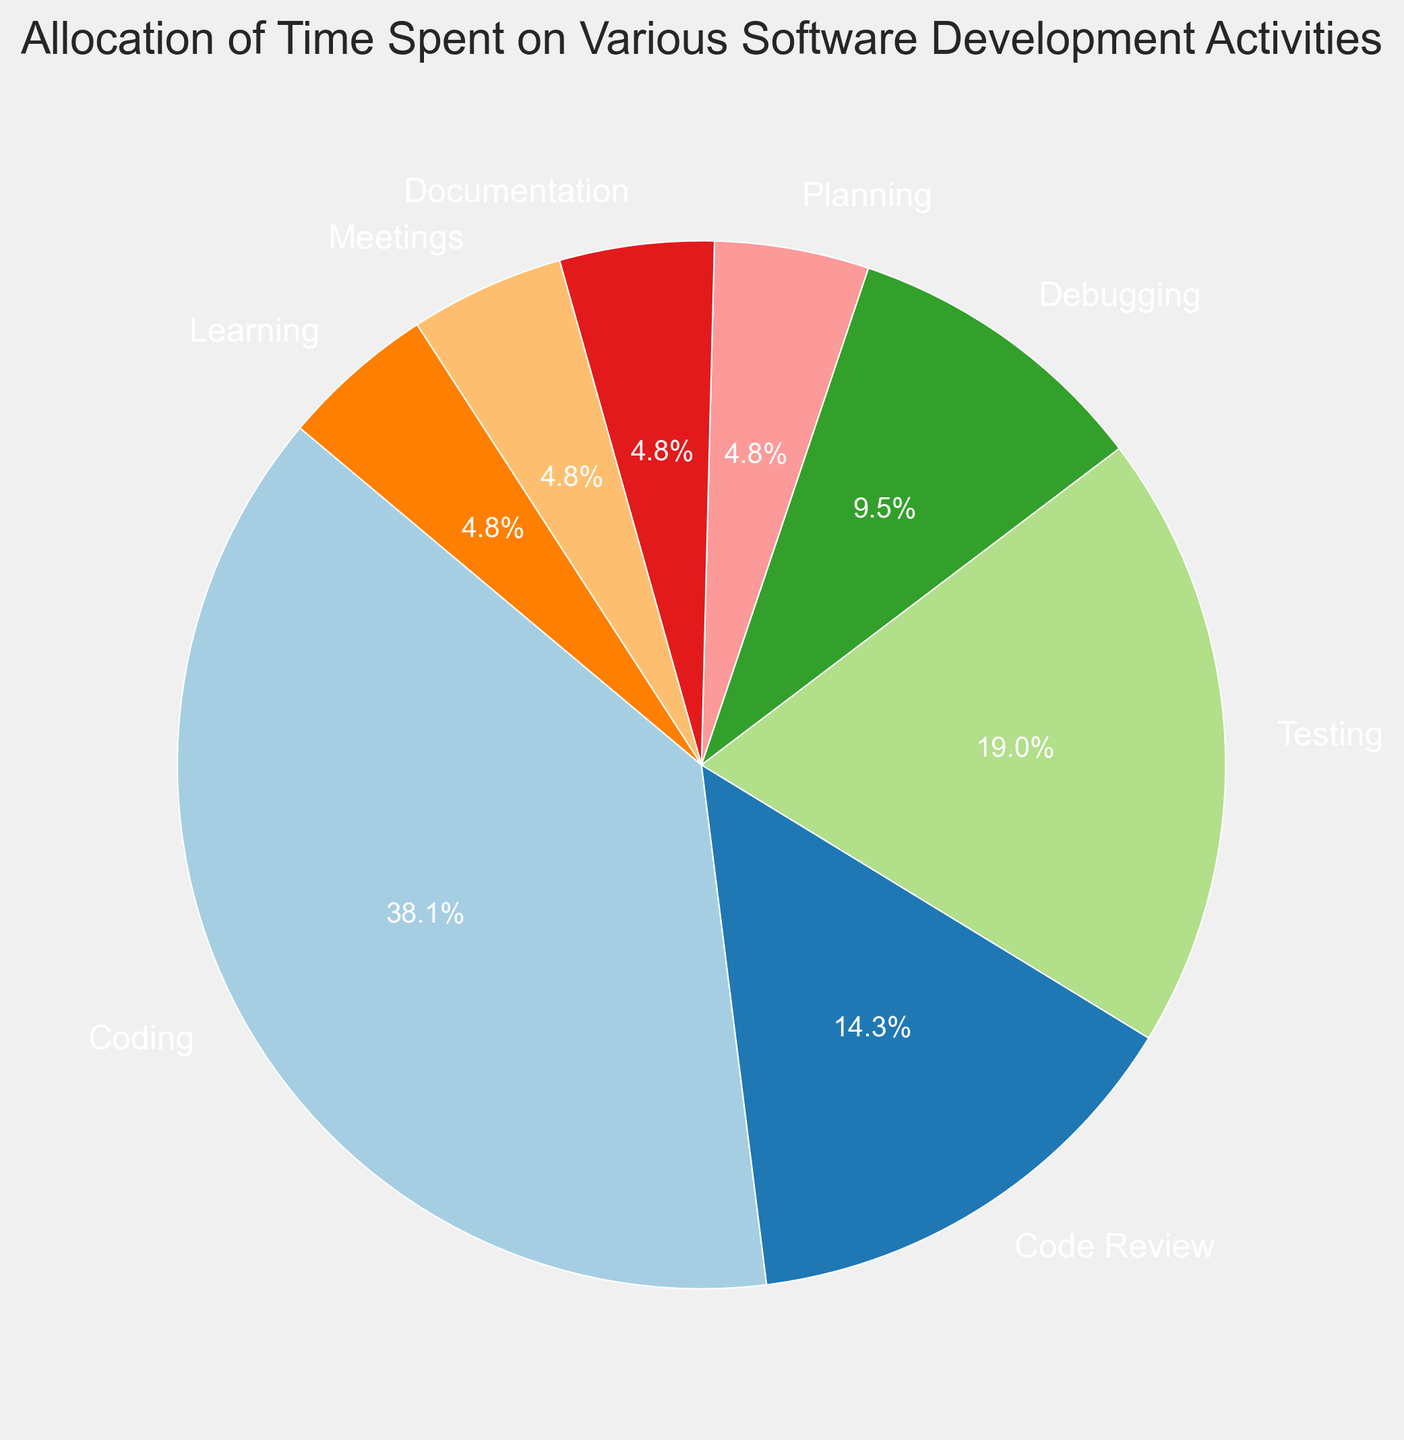What is the most time-consuming activity? To find the most time-consuming activity, look for the category with the highest percentage in the pie chart. 'Coding' takes up 40%, which is the highest value.
Answer: Coding Which activity is allocated the least amount of time? To figure this out, we should look for the category with the smallest percentage in the pie chart. 'Planning', 'Documentation', 'Meetings', and 'Learning' each have 5%, which are the smallest values.
Answer: Planning, Documentation, Meetings, Learning How much more time is spent on Coding compared to Testing? Subtract the percentage allocated to Testing (20%) from the percentage for Coding (40%). So, 40% - 20% = 20%.
Answer: 20% What is the total percentage of time spent on activities other than Coding? Sum all the percentages except for 'Coding': 15% (Code Review) + 20% (Testing) + 10% (Debugging) + 5% (Planning) + 5% (Documentation) + 5% (Meetings) + 5% (Learning) = 65%.
Answer: 65% Is more time spent on Testing or Code Review? Comparing the slices for Testing (20%) and Code Review (15%), Testing has a larger percentage.
Answer: Testing What is the combined percentage of time spent on Planning, Documentation, Meetings, and Learning? Add the percentages for each of these activities: 5% (Planning) + 5% (Documentation) + 5% (Meetings) + 5% (Learning) = 20%.
Answer: 20% By what factor is the time spent on Debugging greater than that on Planning? Divide the percentage for Debugging (10%) by the percentage for Planning (5%): 10% / 5% = 2.
Answer: 2 How does the percentage of time allocated for Debugging compare to that for Documentation? Both Debugging (10%) and Documentation (5%) are slices in the pie chart. Debugging takes up twice as much time as Documentation, 10% is greater than 5%.
Answer: Debugging takes twice as much time If you were to combine the time spent on Code Review and Meetings, what percentage of time would that represent? Add the percentages for Code Review (15%) and Meetings (5%): 15% + 5% = 20%.
Answer: 20% Is the time spent on Learning equal to that spent on Planning? Both Learning and Planning are represented with the same percentage (5%) in the pie chart, which means they are equal.
Answer: Yes 